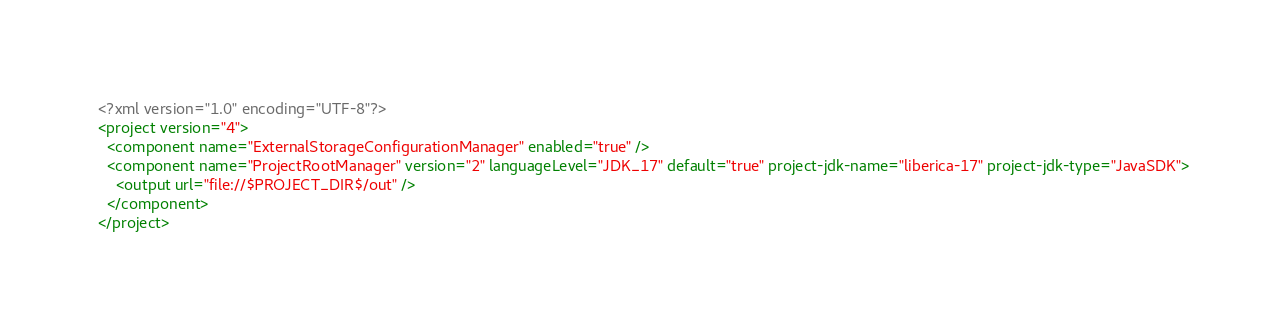<code> <loc_0><loc_0><loc_500><loc_500><_XML_><?xml version="1.0" encoding="UTF-8"?>
<project version="4">
  <component name="ExternalStorageConfigurationManager" enabled="true" />
  <component name="ProjectRootManager" version="2" languageLevel="JDK_17" default="true" project-jdk-name="liberica-17" project-jdk-type="JavaSDK">
    <output url="file://$PROJECT_DIR$/out" />
  </component>
</project></code> 